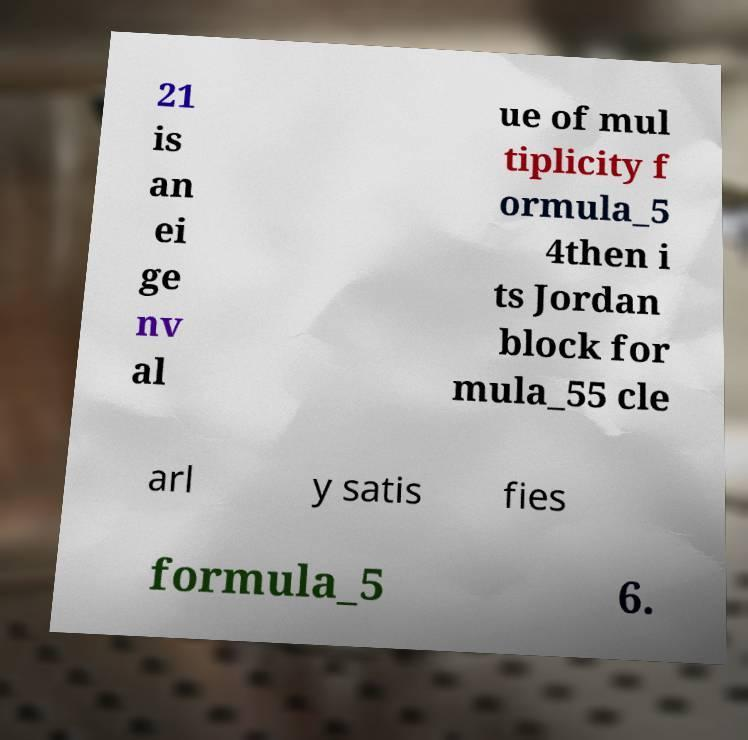Can you read and provide the text displayed in the image?This photo seems to have some interesting text. Can you extract and type it out for me? 21 is an ei ge nv al ue of mul tiplicity f ormula_5 4then i ts Jordan block for mula_55 cle arl y satis fies formula_5 6. 